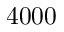<formula> <loc_0><loc_0><loc_500><loc_500>4 0 0 0</formula> 